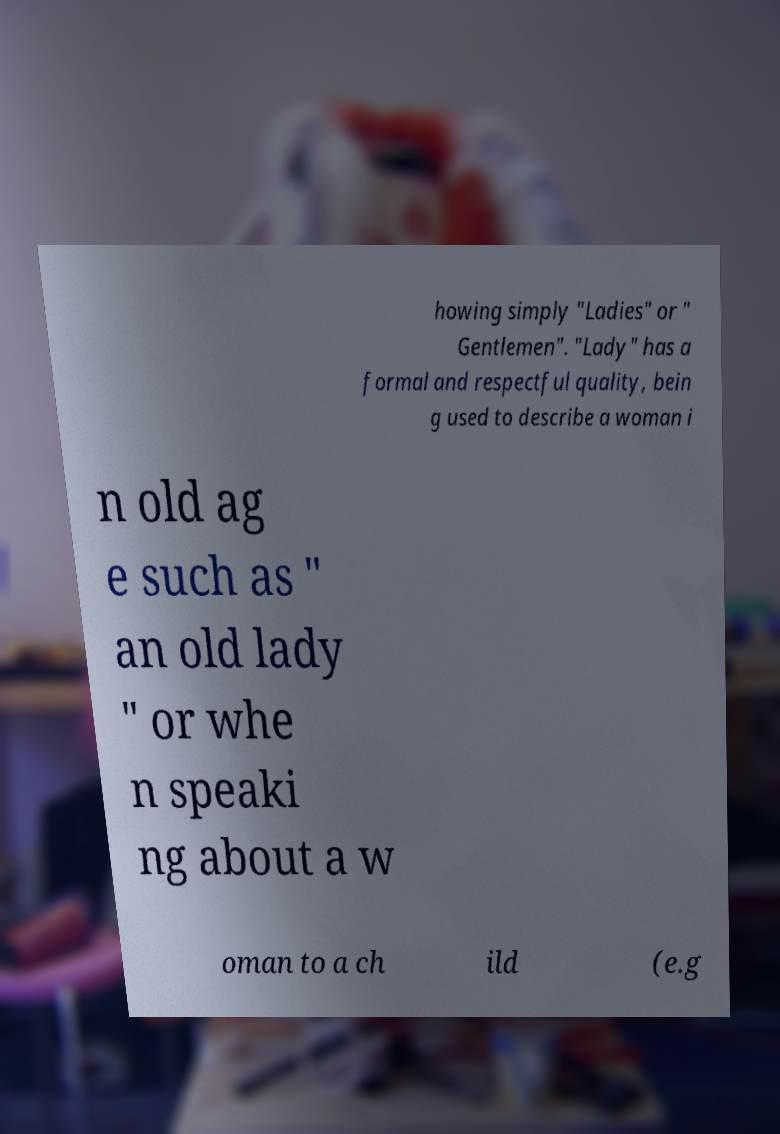Please read and relay the text visible in this image. What does it say? howing simply "Ladies" or " Gentlemen". "Lady" has a formal and respectful quality, bein g used to describe a woman i n old ag e such as " an old lady " or whe n speaki ng about a w oman to a ch ild (e.g 